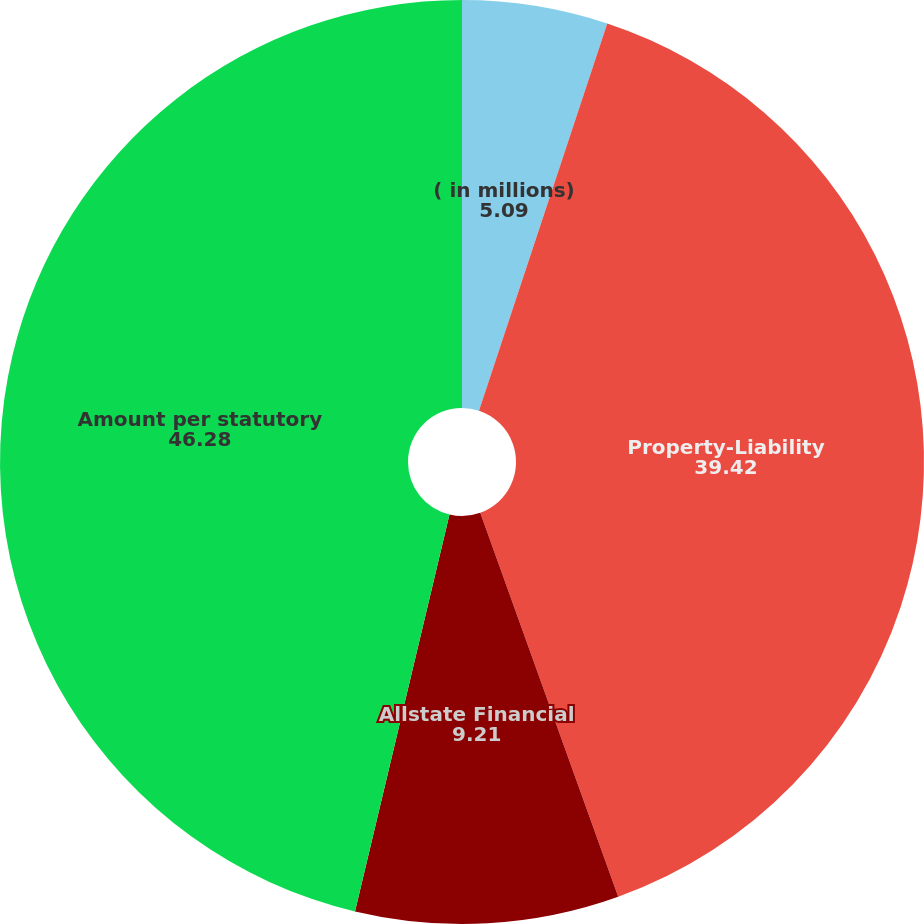Convert chart to OTSL. <chart><loc_0><loc_0><loc_500><loc_500><pie_chart><fcel>( in millions)<fcel>Property-Liability<fcel>Allstate Financial<fcel>Amount per statutory<nl><fcel>5.09%<fcel>39.42%<fcel>9.21%<fcel>46.28%<nl></chart> 